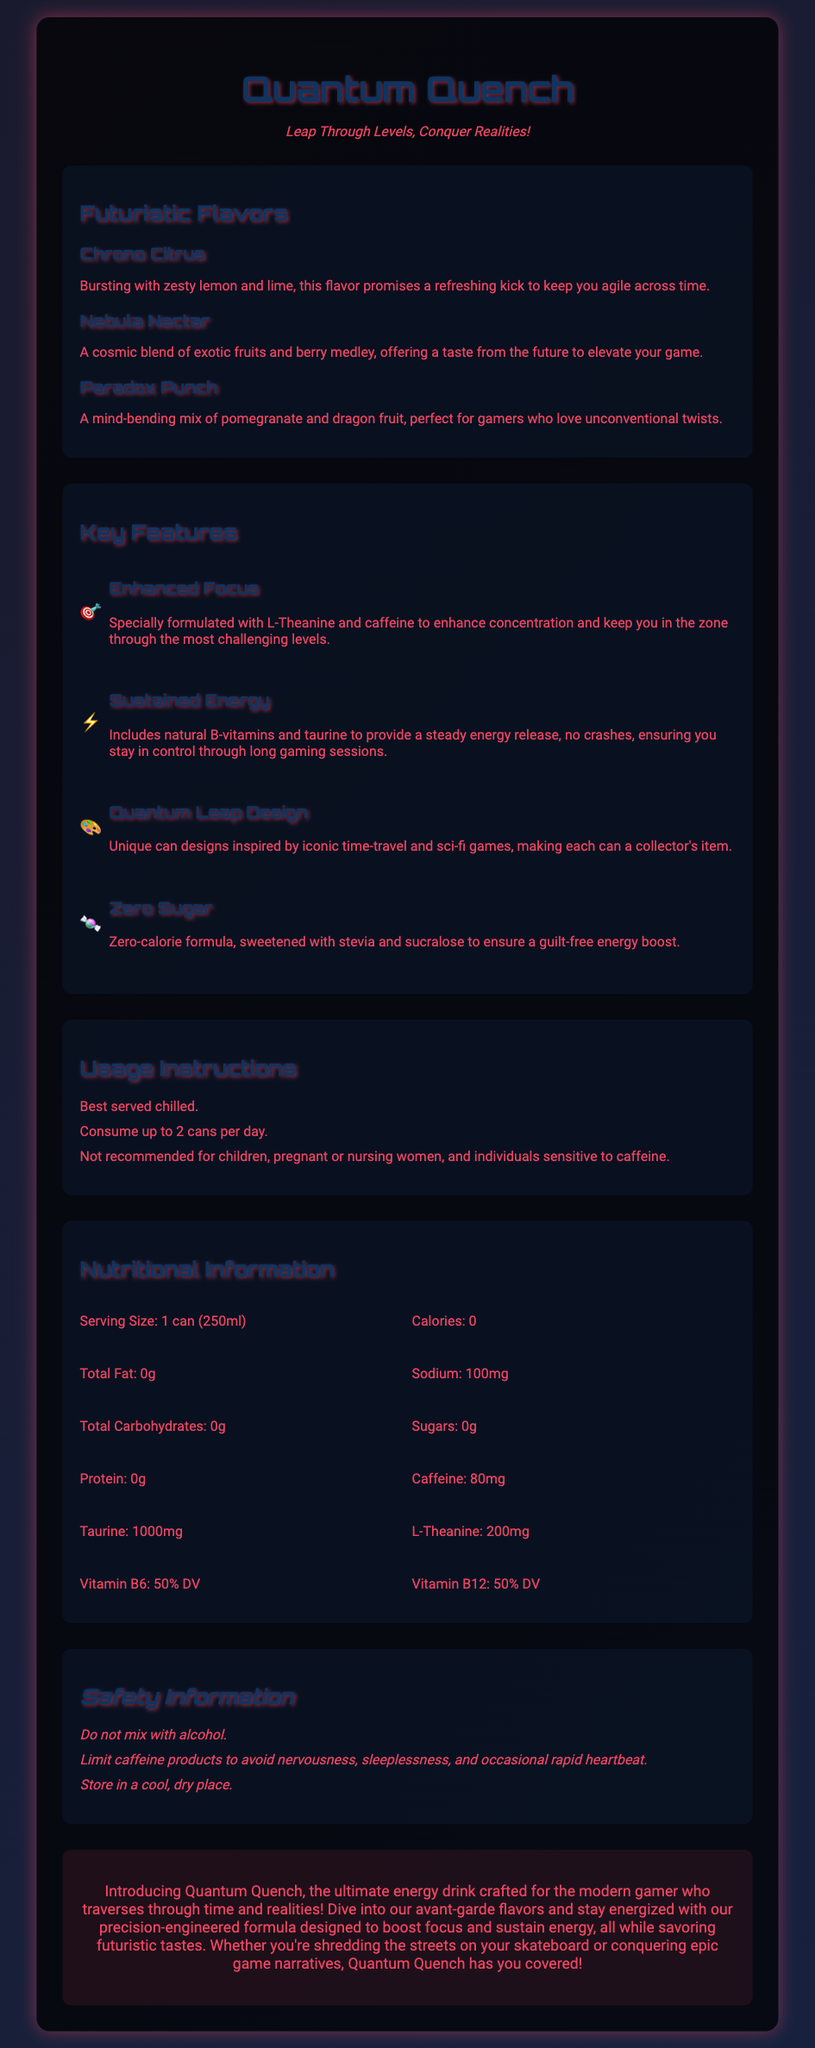What are the futuristic flavors? The document lists three flavors under "Futuristic Flavors": Chrono Citrus, Nebula Nectar, and Paradox Punch.
Answer: Chrono Citrus, Nebula Nectar, Paradox Punch How many cans can be consumed per day? The usage instructions specify that you can consume up to 2 cans per day.
Answer: 2 cans What is the caffeine content in one can? The nutritional information states that each can contains 80mg of caffeine.
Answer: 80mg What key feature is linked to improved concentration? The document highlights "Enhanced Focus" as a feature specially formulated to enhance concentration.
Answer: Enhanced Focus Is the drink zero-calorie? The description of "Zero Sugar" in the key features indicates that it is a zero-calorie formula.
Answer: Yes 